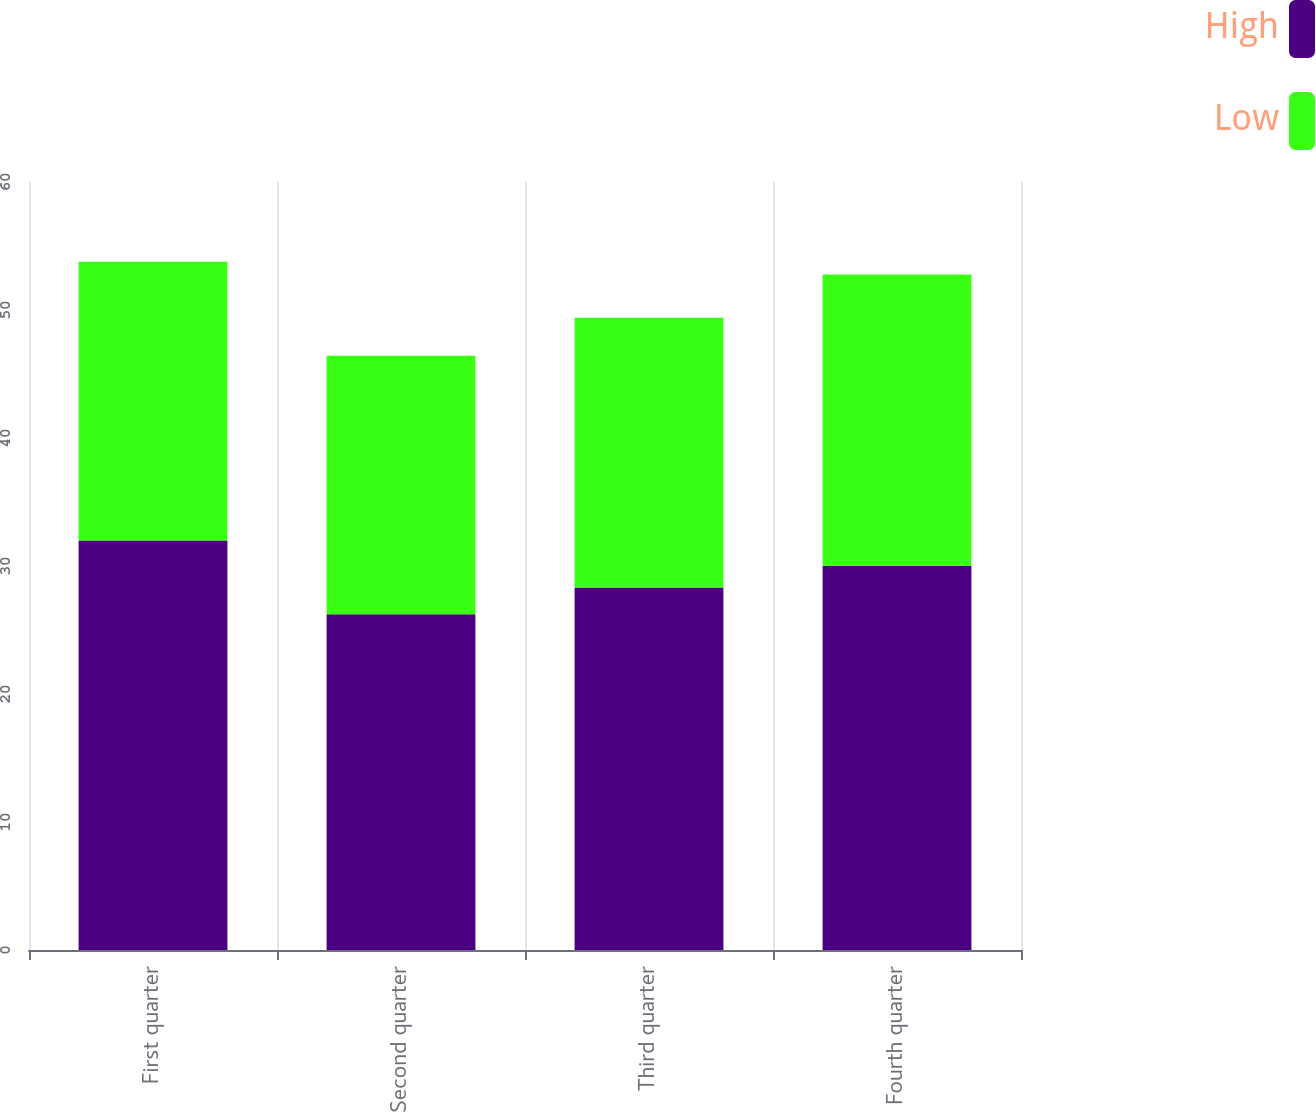Convert chart. <chart><loc_0><loc_0><loc_500><loc_500><stacked_bar_chart><ecel><fcel>First quarter<fcel>Second quarter<fcel>Third quarter<fcel>Fourth quarter<nl><fcel>High<fcel>32<fcel>26.24<fcel>28.32<fcel>30.01<nl><fcel>Low<fcel>21.76<fcel>20.18<fcel>21.07<fcel>22.76<nl></chart> 